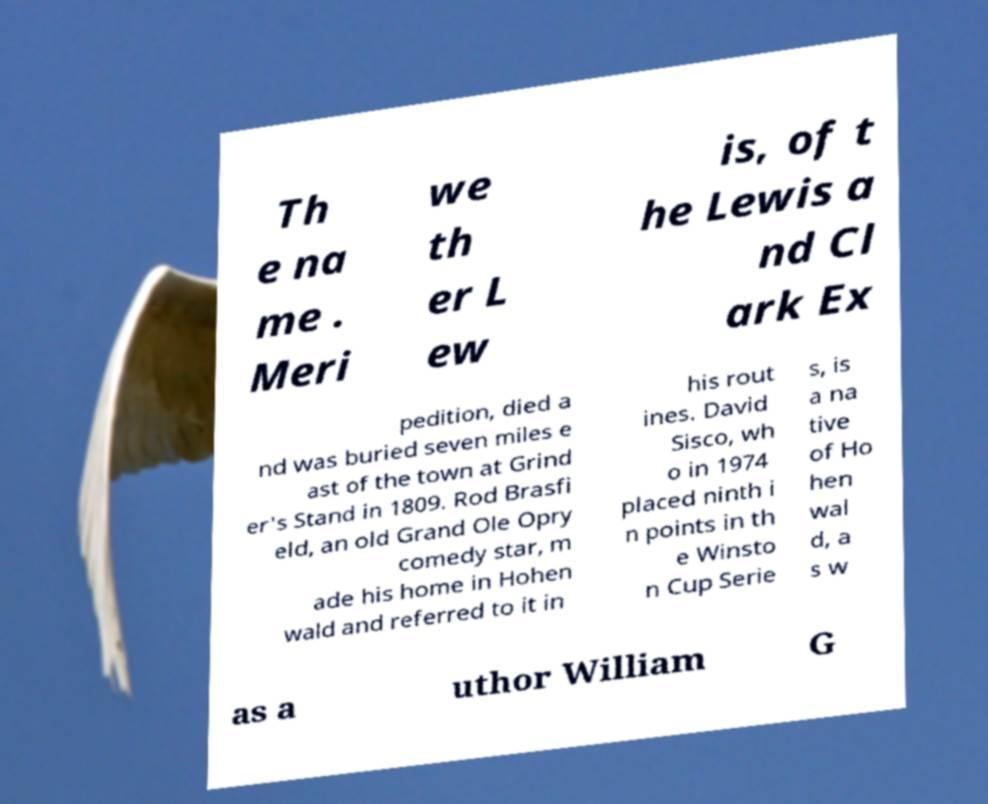Can you accurately transcribe the text from the provided image for me? Th e na me . Meri we th er L ew is, of t he Lewis a nd Cl ark Ex pedition, died a nd was buried seven miles e ast of the town at Grind er's Stand in 1809. Rod Brasfi eld, an old Grand Ole Opry comedy star, m ade his home in Hohen wald and referred to it in his rout ines. David Sisco, wh o in 1974 placed ninth i n points in th e Winsto n Cup Serie s, is a na tive of Ho hen wal d, a s w as a uthor William G 